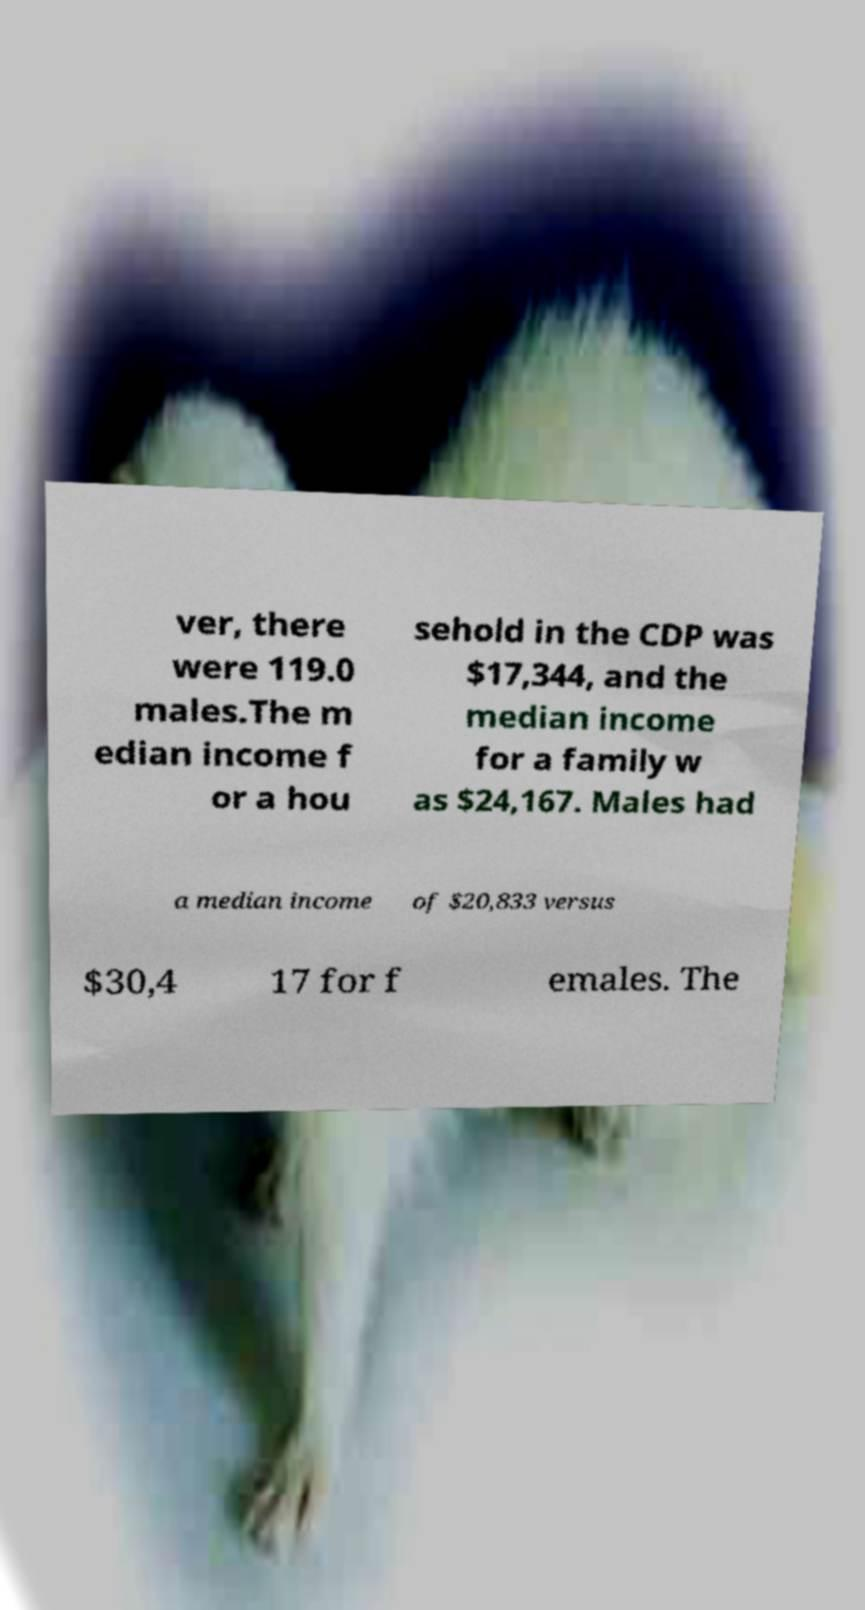Could you assist in decoding the text presented in this image and type it out clearly? ver, there were 119.0 males.The m edian income f or a hou sehold in the CDP was $17,344, and the median income for a family w as $24,167. Males had a median income of $20,833 versus $30,4 17 for f emales. The 